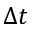<formula> <loc_0><loc_0><loc_500><loc_500>\Delta t</formula> 